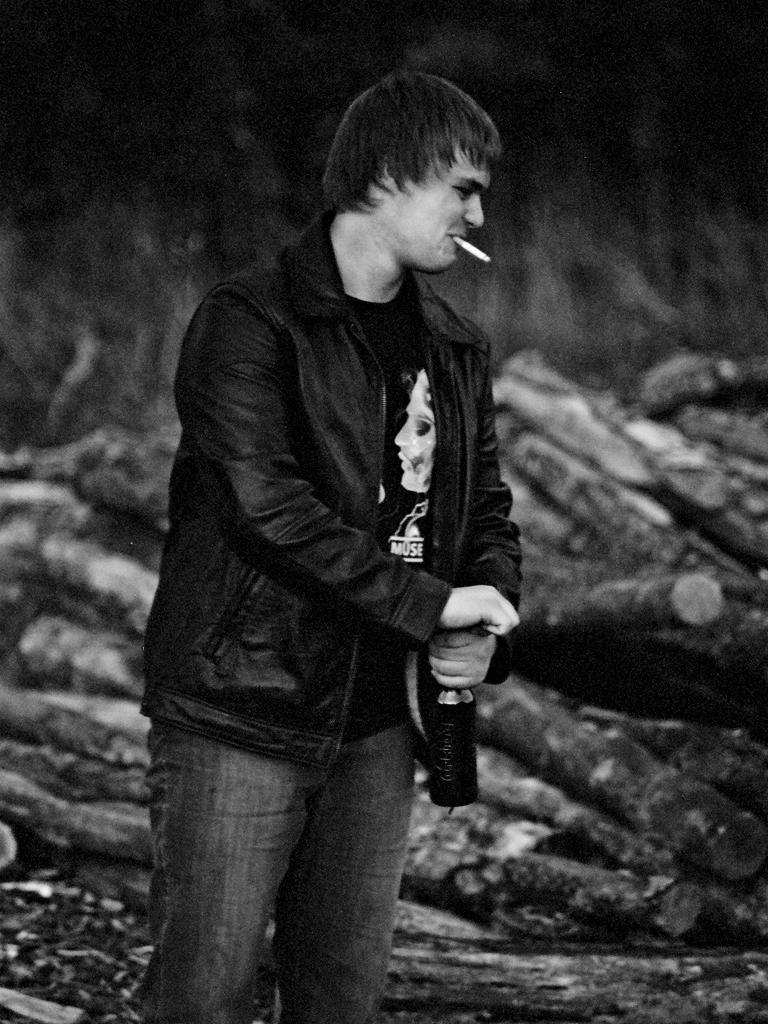What is the person in the image doing? The person is standing in the image. What object is the person holding? The person is holding a bottle. What can be seen in the background of the image? There are wooden logs in the background of the image. What type of cactus can be seen growing near the person in the image? There is no cactus present in the image. What color is the flower that the person is holding in the image? The person is not holding a flower in the image; they are holding a bottle. 